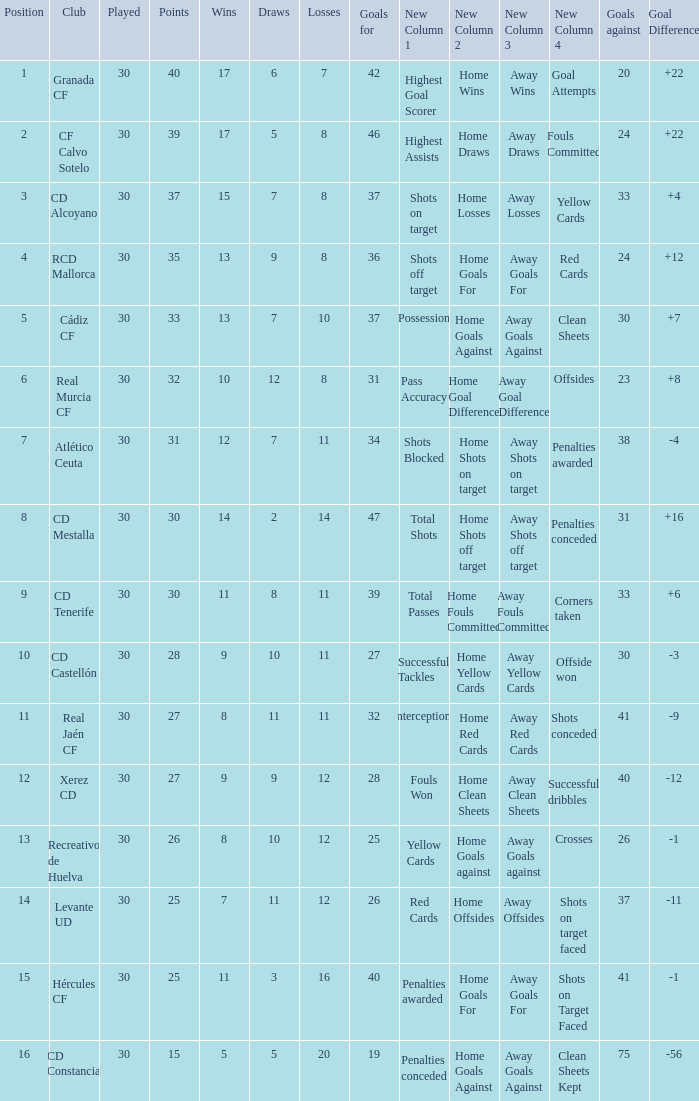Which Wins have a Goal Difference larger than 12, and a Club of granada cf, and Played larger than 30? None. 